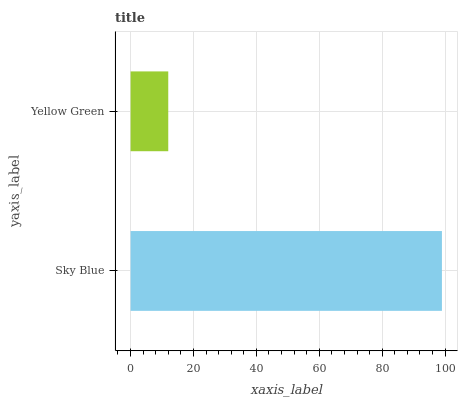Is Yellow Green the minimum?
Answer yes or no. Yes. Is Sky Blue the maximum?
Answer yes or no. Yes. Is Yellow Green the maximum?
Answer yes or no. No. Is Sky Blue greater than Yellow Green?
Answer yes or no. Yes. Is Yellow Green less than Sky Blue?
Answer yes or no. Yes. Is Yellow Green greater than Sky Blue?
Answer yes or no. No. Is Sky Blue less than Yellow Green?
Answer yes or no. No. Is Sky Blue the high median?
Answer yes or no. Yes. Is Yellow Green the low median?
Answer yes or no. Yes. Is Yellow Green the high median?
Answer yes or no. No. Is Sky Blue the low median?
Answer yes or no. No. 